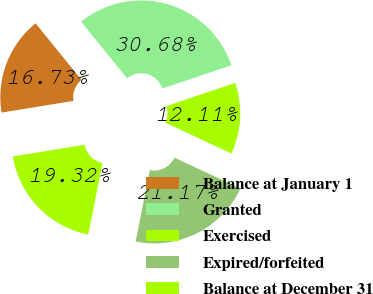Convert chart. <chart><loc_0><loc_0><loc_500><loc_500><pie_chart><fcel>Balance at January 1<fcel>Granted<fcel>Exercised<fcel>Expired/forfeited<fcel>Balance at December 31<nl><fcel>16.73%<fcel>30.68%<fcel>12.11%<fcel>21.17%<fcel>19.32%<nl></chart> 